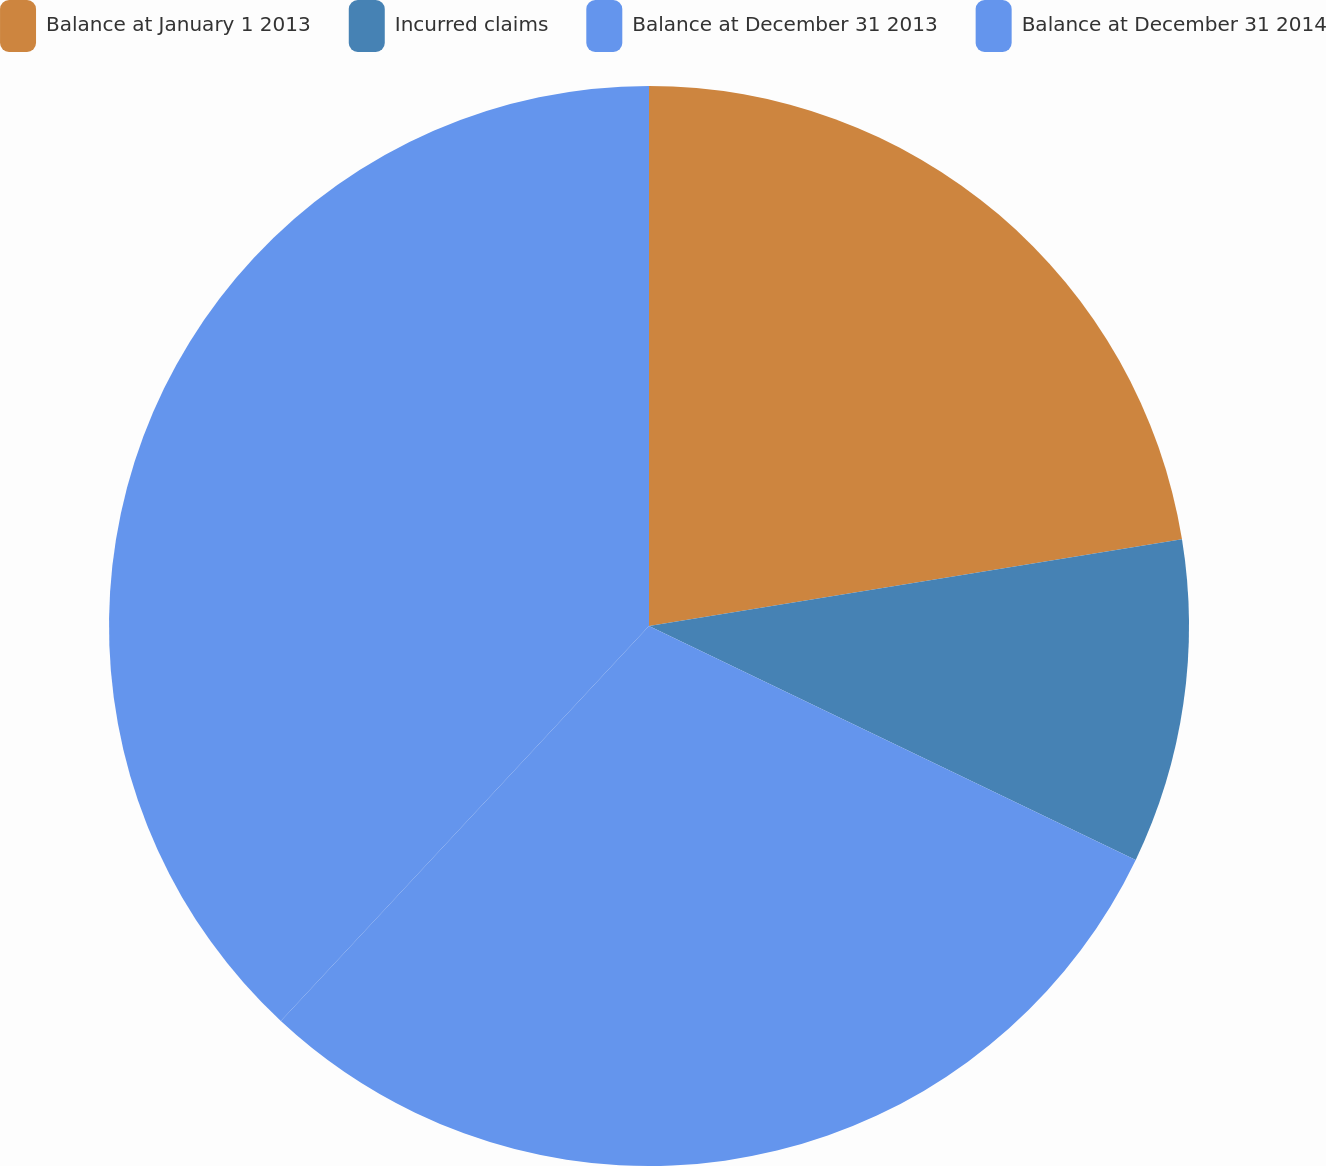Convert chart to OTSL. <chart><loc_0><loc_0><loc_500><loc_500><pie_chart><fcel>Balance at January 1 2013<fcel>Incurred claims<fcel>Balance at December 31 2013<fcel>Balance at December 31 2014<nl><fcel>22.43%<fcel>9.7%<fcel>29.81%<fcel>38.06%<nl></chart> 